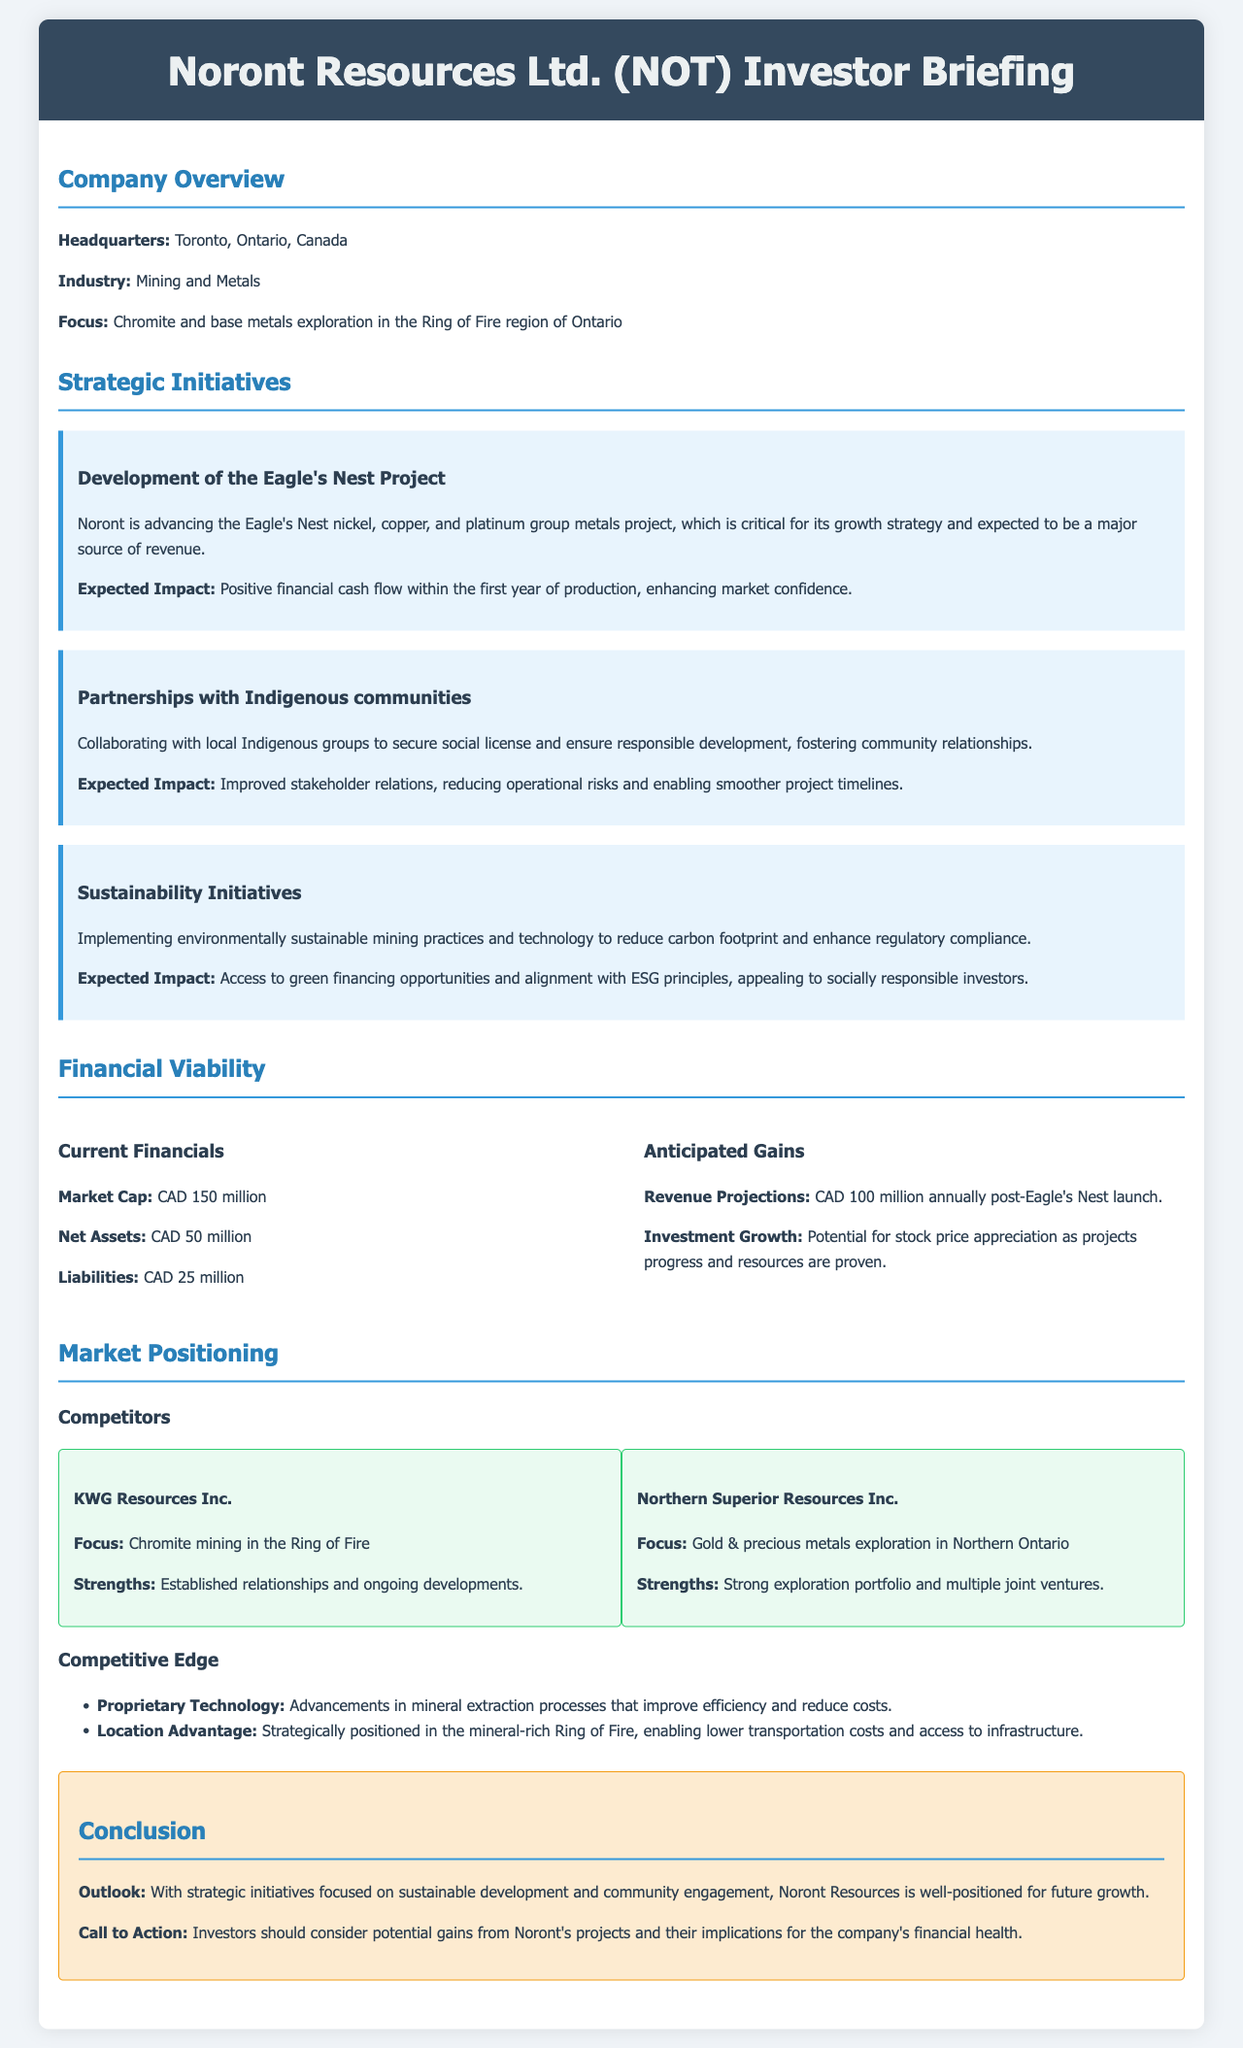what is the headquarters location of Noront Resources? The headquarters location is mentioned directly in the document as Toronto, Ontario, Canada.
Answer: Toronto, Ontario, Canada what is Noront Resources' market capitalization? The document states the market capitalization under current financials, which is CAD 150 million.
Answer: CAD 150 million what project is critical for Noront's growth strategy? The project that is essential for growth is identified in the strategic initiatives section as the Eagle's Nest Project.
Answer: Eagle's Nest Project what is the anticipated annual revenue post-launch of Eagle's Nest? The anticipated annual revenue is specified in the financials section, indicating CAD 100 million annually.
Answer: CAD 100 million how does Noront's partnership with Indigenous communities impact operations? The impact of the partnerships on operations is linked to improved stakeholder relations, thereby reducing operational risks.
Answer: Improved stakeholder relations what are Noront's two main competitors? The document lists KWG Resources Inc. and Northern Superior Resources Inc. as the main competitors of Noront Resources.
Answer: KWG Resources Inc. and Northern Superior Resources Inc what is the location advantage mentioned for Noront Resources? The location advantage mentioned refers to being strategically positioned in the mineral-rich Ring of Fire.
Answer: In the mineral-rich Ring of Fire what is the call to action for investors at the conclusion? The call to action for investors emphasizes considering potential gains from Noront's projects and their implications for financial health.
Answer: Consider potential gains from Noront's projects 